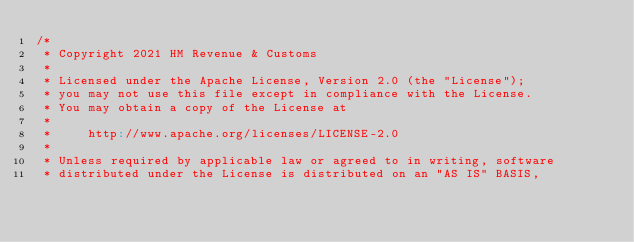Convert code to text. <code><loc_0><loc_0><loc_500><loc_500><_Scala_>/*
 * Copyright 2021 HM Revenue & Customs
 *
 * Licensed under the Apache License, Version 2.0 (the "License");
 * you may not use this file except in compliance with the License.
 * You may obtain a copy of the License at
 *
 *     http://www.apache.org/licenses/LICENSE-2.0
 *
 * Unless required by applicable law or agreed to in writing, software
 * distributed under the License is distributed on an "AS IS" BASIS,</code> 